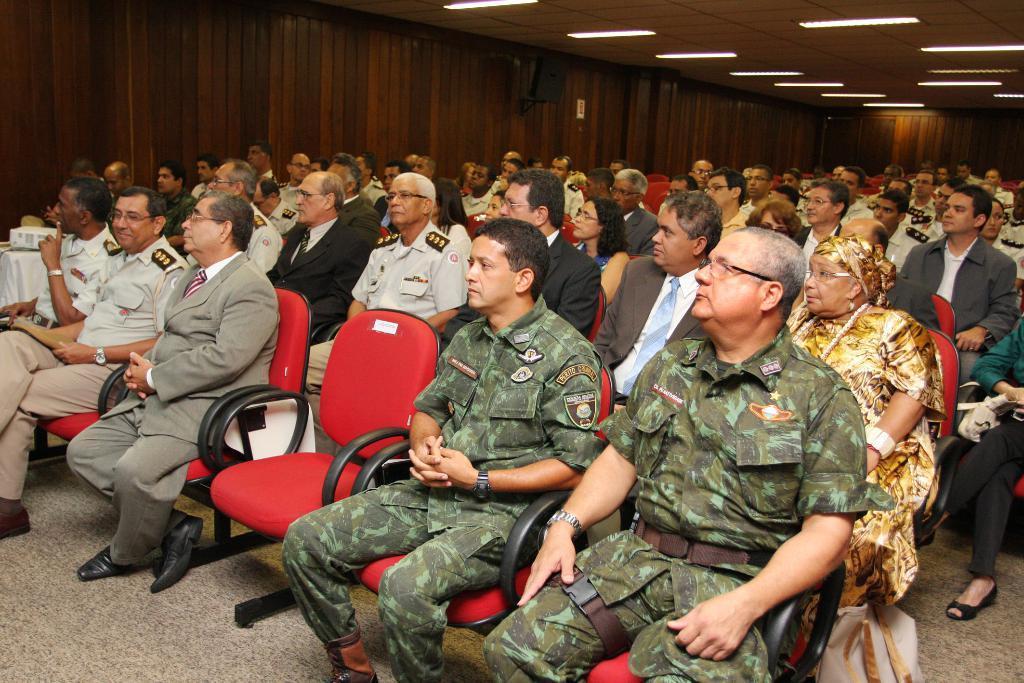How would you summarize this image in a sentence or two? In the picture there are many people present sitting on the chairs, there are many lights present on the roof. 